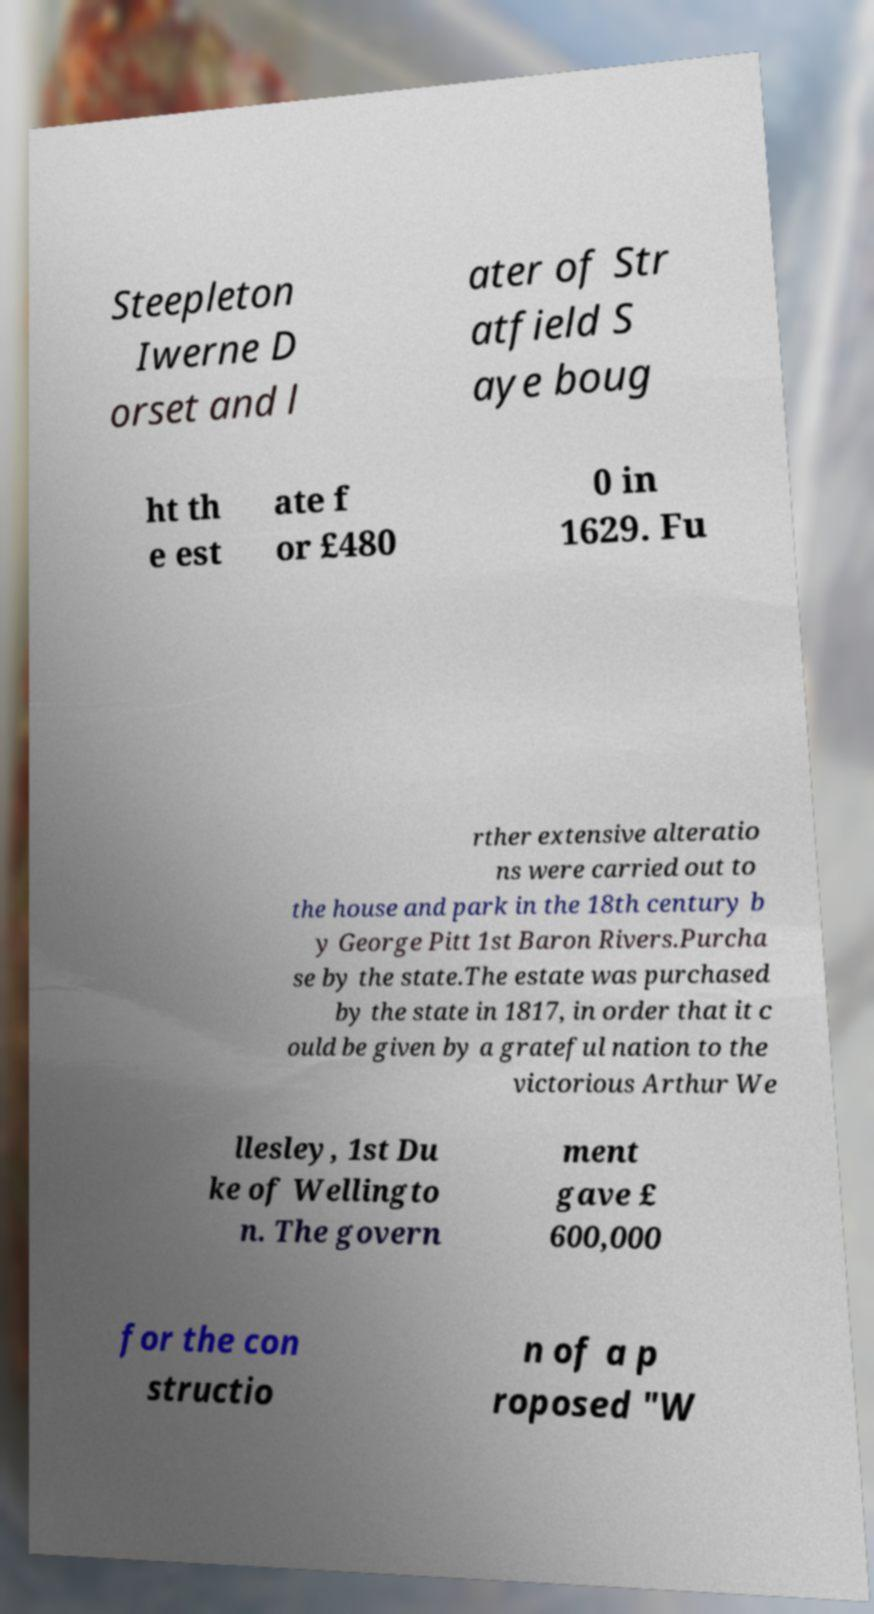For documentation purposes, I need the text within this image transcribed. Could you provide that? Steepleton Iwerne D orset and l ater of Str atfield S aye boug ht th e est ate f or £480 0 in 1629. Fu rther extensive alteratio ns were carried out to the house and park in the 18th century b y George Pitt 1st Baron Rivers.Purcha se by the state.The estate was purchased by the state in 1817, in order that it c ould be given by a grateful nation to the victorious Arthur We llesley, 1st Du ke of Wellingto n. The govern ment gave £ 600,000 for the con structio n of a p roposed "W 